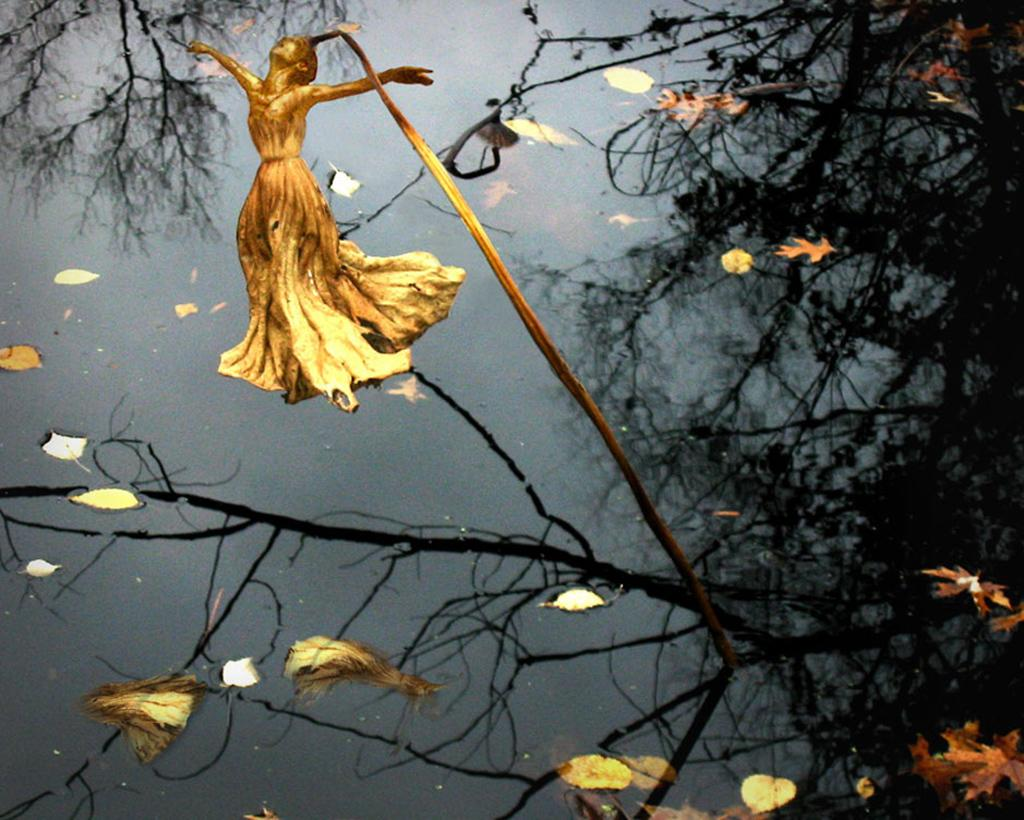What is the primary element visible in the image? There is water in the image. What is floating on the surface of the water? There are leaves on the surface of the water. What type of flower can be seen in the image? There is a yellow-colored flower in the shape of a person in the image. Is the flower part of a plant? Yes, the flower is associated with a plant. Can you tell me how many boats are visible in the image? There are no boats present in the image; it features water with leaves and a yellow-colored flower. What type of juice is being requested in the image? There is no request for juice in the image; it only shows water, leaves, and the flower. 